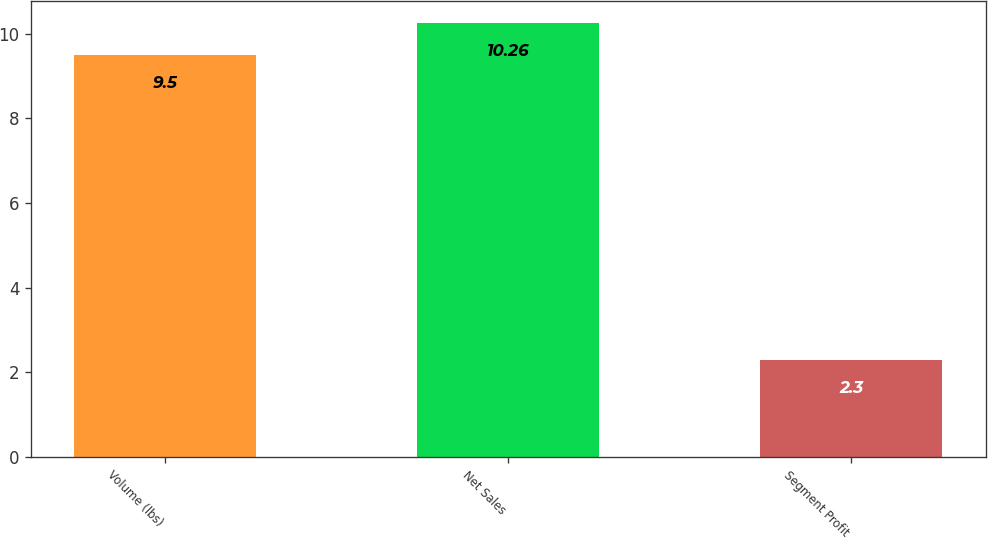Convert chart. <chart><loc_0><loc_0><loc_500><loc_500><bar_chart><fcel>Volume (lbs)<fcel>Net Sales<fcel>Segment Profit<nl><fcel>9.5<fcel>10.26<fcel>2.3<nl></chart> 